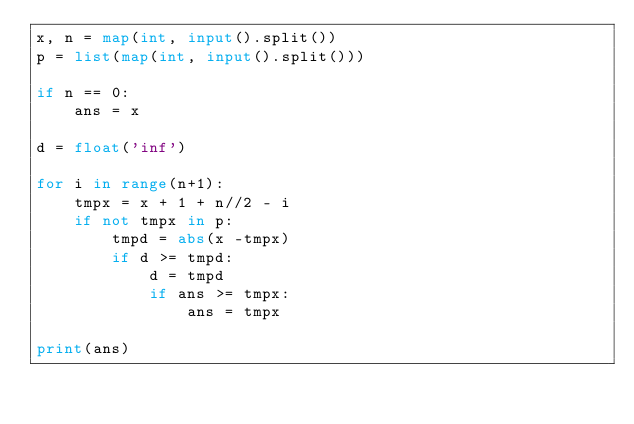<code> <loc_0><loc_0><loc_500><loc_500><_Python_>x, n = map(int, input().split())
p = list(map(int, input().split()))

if n == 0:
    ans = x

d = float('inf')

for i in range(n+1):
    tmpx = x + 1 + n//2 - i
    if not tmpx in p:
        tmpd = abs(x -tmpx) 
        if d >= tmpd:
            d = tmpd
            if ans >= tmpx:
                ans = tmpx

print(ans)


</code> 